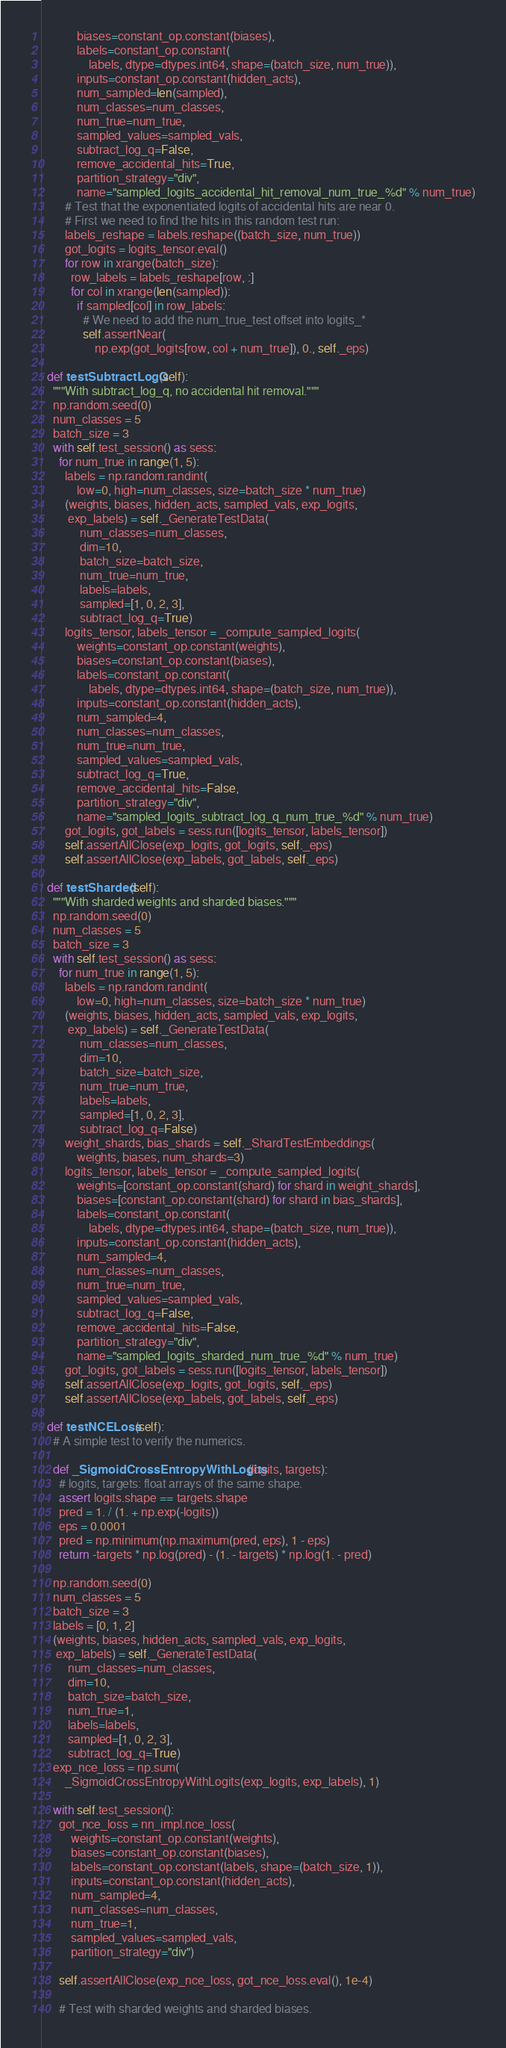<code> <loc_0><loc_0><loc_500><loc_500><_Python_>            biases=constant_op.constant(biases),
            labels=constant_op.constant(
                labels, dtype=dtypes.int64, shape=(batch_size, num_true)),
            inputs=constant_op.constant(hidden_acts),
            num_sampled=len(sampled),
            num_classes=num_classes,
            num_true=num_true,
            sampled_values=sampled_vals,
            subtract_log_q=False,
            remove_accidental_hits=True,
            partition_strategy="div",
            name="sampled_logits_accidental_hit_removal_num_true_%d" % num_true)
        # Test that the exponentiated logits of accidental hits are near 0.
        # First we need to find the hits in this random test run:
        labels_reshape = labels.reshape((batch_size, num_true))
        got_logits = logits_tensor.eval()
        for row in xrange(batch_size):
          row_labels = labels_reshape[row, :]
          for col in xrange(len(sampled)):
            if sampled[col] in row_labels:
              # We need to add the num_true_test offset into logits_*
              self.assertNear(
                  np.exp(got_logits[row, col + num_true]), 0., self._eps)

  def testSubtractLogQ(self):
    """With subtract_log_q, no accidental hit removal."""
    np.random.seed(0)
    num_classes = 5
    batch_size = 3
    with self.test_session() as sess:
      for num_true in range(1, 5):
        labels = np.random.randint(
            low=0, high=num_classes, size=batch_size * num_true)
        (weights, biases, hidden_acts, sampled_vals, exp_logits,
         exp_labels) = self._GenerateTestData(
             num_classes=num_classes,
             dim=10,
             batch_size=batch_size,
             num_true=num_true,
             labels=labels,
             sampled=[1, 0, 2, 3],
             subtract_log_q=True)
        logits_tensor, labels_tensor = _compute_sampled_logits(
            weights=constant_op.constant(weights),
            biases=constant_op.constant(biases),
            labels=constant_op.constant(
                labels, dtype=dtypes.int64, shape=(batch_size, num_true)),
            inputs=constant_op.constant(hidden_acts),
            num_sampled=4,
            num_classes=num_classes,
            num_true=num_true,
            sampled_values=sampled_vals,
            subtract_log_q=True,
            remove_accidental_hits=False,
            partition_strategy="div",
            name="sampled_logits_subtract_log_q_num_true_%d" % num_true)
        got_logits, got_labels = sess.run([logits_tensor, labels_tensor])
        self.assertAllClose(exp_logits, got_logits, self._eps)
        self.assertAllClose(exp_labels, got_labels, self._eps)

  def testSharded(self):
    """With sharded weights and sharded biases."""
    np.random.seed(0)
    num_classes = 5
    batch_size = 3
    with self.test_session() as sess:
      for num_true in range(1, 5):
        labels = np.random.randint(
            low=0, high=num_classes, size=batch_size * num_true)
        (weights, biases, hidden_acts, sampled_vals, exp_logits,
         exp_labels) = self._GenerateTestData(
             num_classes=num_classes,
             dim=10,
             batch_size=batch_size,
             num_true=num_true,
             labels=labels,
             sampled=[1, 0, 2, 3],
             subtract_log_q=False)
        weight_shards, bias_shards = self._ShardTestEmbeddings(
            weights, biases, num_shards=3)
        logits_tensor, labels_tensor = _compute_sampled_logits(
            weights=[constant_op.constant(shard) for shard in weight_shards],
            biases=[constant_op.constant(shard) for shard in bias_shards],
            labels=constant_op.constant(
                labels, dtype=dtypes.int64, shape=(batch_size, num_true)),
            inputs=constant_op.constant(hidden_acts),
            num_sampled=4,
            num_classes=num_classes,
            num_true=num_true,
            sampled_values=sampled_vals,
            subtract_log_q=False,
            remove_accidental_hits=False,
            partition_strategy="div",
            name="sampled_logits_sharded_num_true_%d" % num_true)
        got_logits, got_labels = sess.run([logits_tensor, labels_tensor])
        self.assertAllClose(exp_logits, got_logits, self._eps)
        self.assertAllClose(exp_labels, got_labels, self._eps)

  def testNCELoss(self):
    # A simple test to verify the numerics.

    def _SigmoidCrossEntropyWithLogits(logits, targets):
      # logits, targets: float arrays of the same shape.
      assert logits.shape == targets.shape
      pred = 1. / (1. + np.exp(-logits))
      eps = 0.0001
      pred = np.minimum(np.maximum(pred, eps), 1 - eps)
      return -targets * np.log(pred) - (1. - targets) * np.log(1. - pred)

    np.random.seed(0)
    num_classes = 5
    batch_size = 3
    labels = [0, 1, 2]
    (weights, biases, hidden_acts, sampled_vals, exp_logits,
     exp_labels) = self._GenerateTestData(
         num_classes=num_classes,
         dim=10,
         batch_size=batch_size,
         num_true=1,
         labels=labels,
         sampled=[1, 0, 2, 3],
         subtract_log_q=True)
    exp_nce_loss = np.sum(
        _SigmoidCrossEntropyWithLogits(exp_logits, exp_labels), 1)

    with self.test_session():
      got_nce_loss = nn_impl.nce_loss(
          weights=constant_op.constant(weights),
          biases=constant_op.constant(biases),
          labels=constant_op.constant(labels, shape=(batch_size, 1)),
          inputs=constant_op.constant(hidden_acts),
          num_sampled=4,
          num_classes=num_classes,
          num_true=1,
          sampled_values=sampled_vals,
          partition_strategy="div")

      self.assertAllClose(exp_nce_loss, got_nce_loss.eval(), 1e-4)

      # Test with sharded weights and sharded biases.</code> 